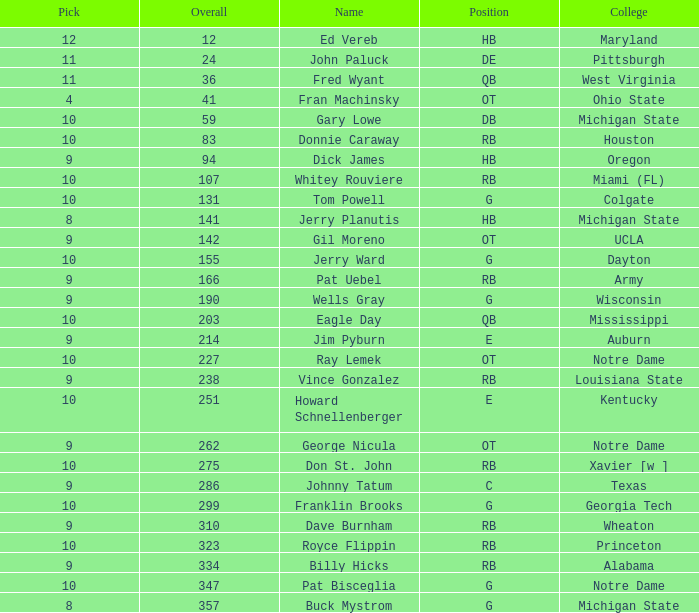What is the maximum round figure for donnie caraway? 7.0. 